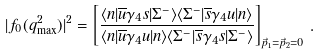Convert formula to latex. <formula><loc_0><loc_0><loc_500><loc_500>| f _ { 0 } ( q ^ { 2 } _ { \max } ) | ^ { 2 } = \left [ \frac { \langle n | \overline { u } \gamma _ { 4 } s | \Sigma ^ { - } \rangle \langle \Sigma ^ { - } | \overline { s } \gamma _ { 4 } u | n \rangle } { \langle n | \overline { u } \gamma _ { 4 } u | n \rangle \langle \Sigma ^ { - } | \overline { s } \gamma _ { 4 } s | \Sigma ^ { - } \rangle } \right ] _ { \vec { p } _ { 1 } = \vec { p } _ { 2 } = 0 } \, .</formula> 